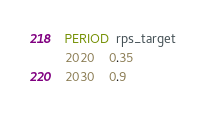<code> <loc_0><loc_0><loc_500><loc_500><_SQL_>PERIOD  rps_target
2020    0.35
2030    0.9
</code> 